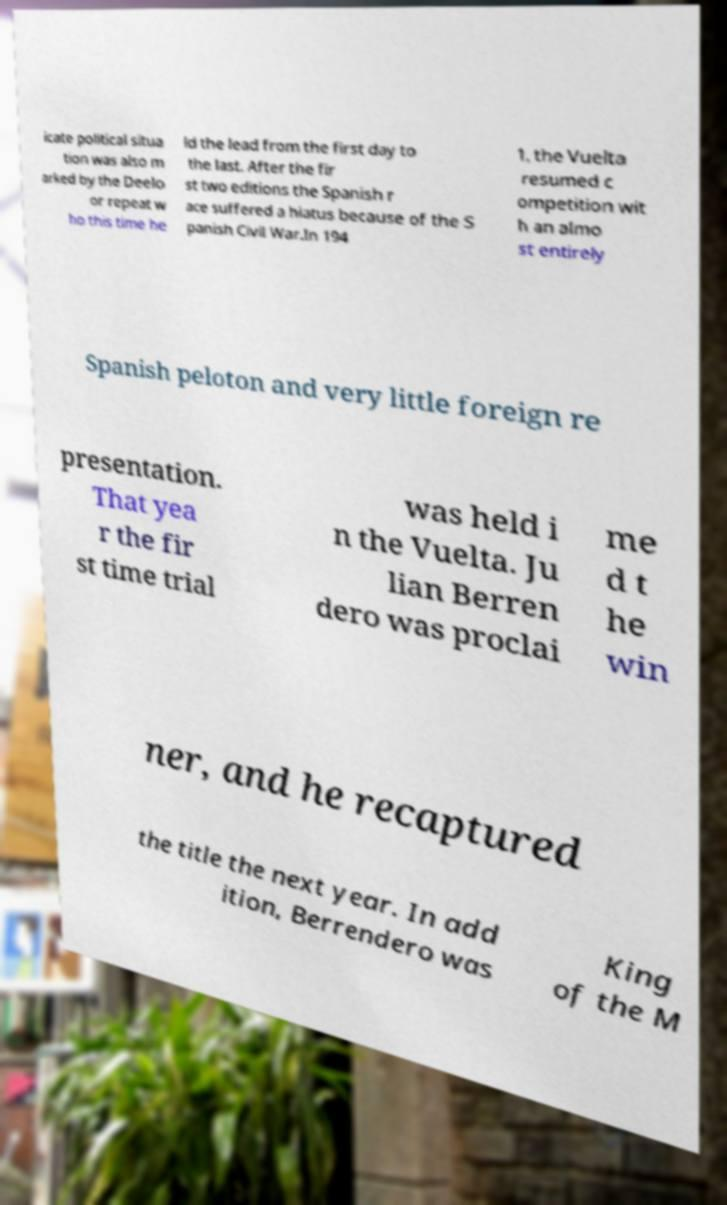Please read and relay the text visible in this image. What does it say? icate political situa tion was also m arked by the Deelo or repeat w ho this time he ld the lead from the first day to the last. After the fir st two editions the Spanish r ace suffered a hiatus because of the S panish Civil War.In 194 1, the Vuelta resumed c ompetition wit h an almo st entirely Spanish peloton and very little foreign re presentation. That yea r the fir st time trial was held i n the Vuelta. Ju lian Berren dero was proclai me d t he win ner, and he recaptured the title the next year. In add ition, Berrendero was King of the M 